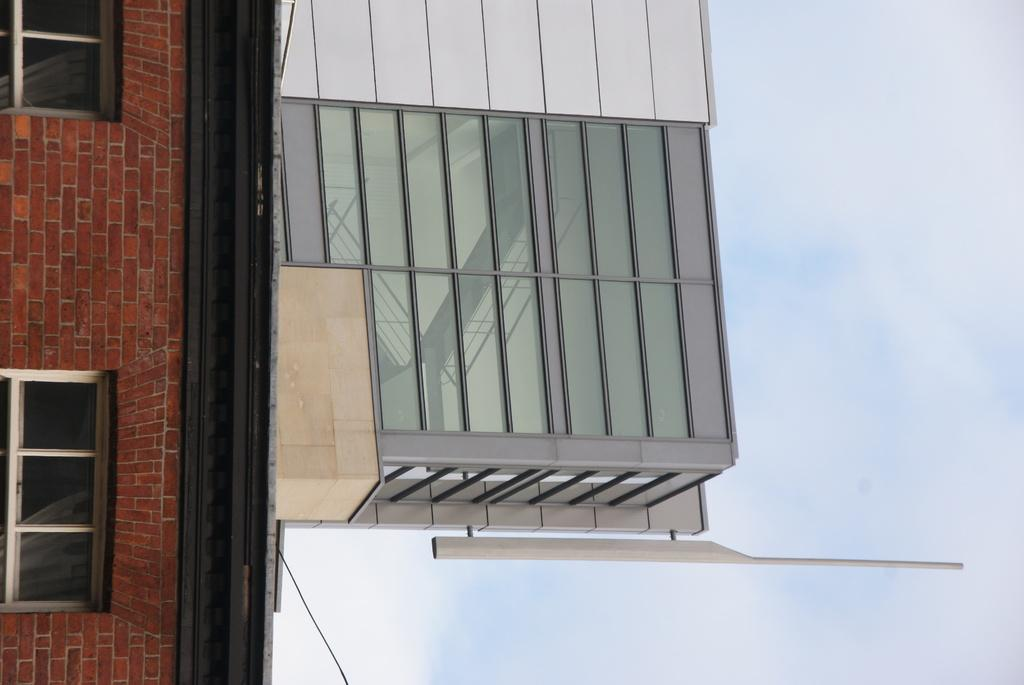What structure is present in the image? There is a building in the image. How many windows can be seen on the building? There are two windows in the image. What else is present in the image besides the building? There is a wire in the image. What can be seen on the right side of the image? Clouds and the sky are visible on the right side of the image. How many mice are hiding behind the building in the image? There are no mice present in the image. What type of beef is being cooked on the wire in the image? There is no beef or any cooking activity depicted in the image; it only features a wire. 